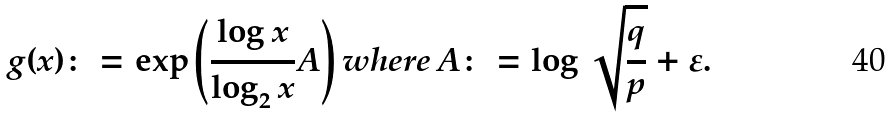Convert formula to latex. <formula><loc_0><loc_0><loc_500><loc_500>g ( x ) \colon = \exp { \left ( \frac { \log { x } } { \log _ { 2 } { x } } A \right ) } \, w h e r e \, A \colon = \log { \sqrt { \frac { q } { p } } } + \varepsilon .</formula> 